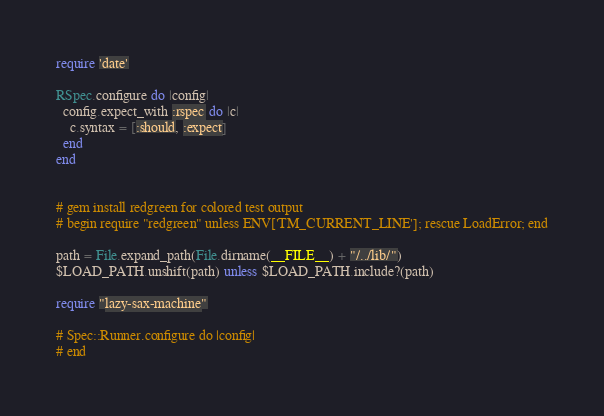Convert code to text. <code><loc_0><loc_0><loc_500><loc_500><_Ruby_>require 'date'

RSpec.configure do |config|
  config.expect_with :rspec do |c|
    c.syntax = [:should, :expect]
  end
end


# gem install redgreen for colored test output
# begin require "redgreen" unless ENV['TM_CURRENT_LINE']; rescue LoadError; end

path = File.expand_path(File.dirname(__FILE__) + "/../lib/")
$LOAD_PATH.unshift(path) unless $LOAD_PATH.include?(path)

require "lazy-sax-machine"

# Spec::Runner.configure do |config|
# end
</code> 